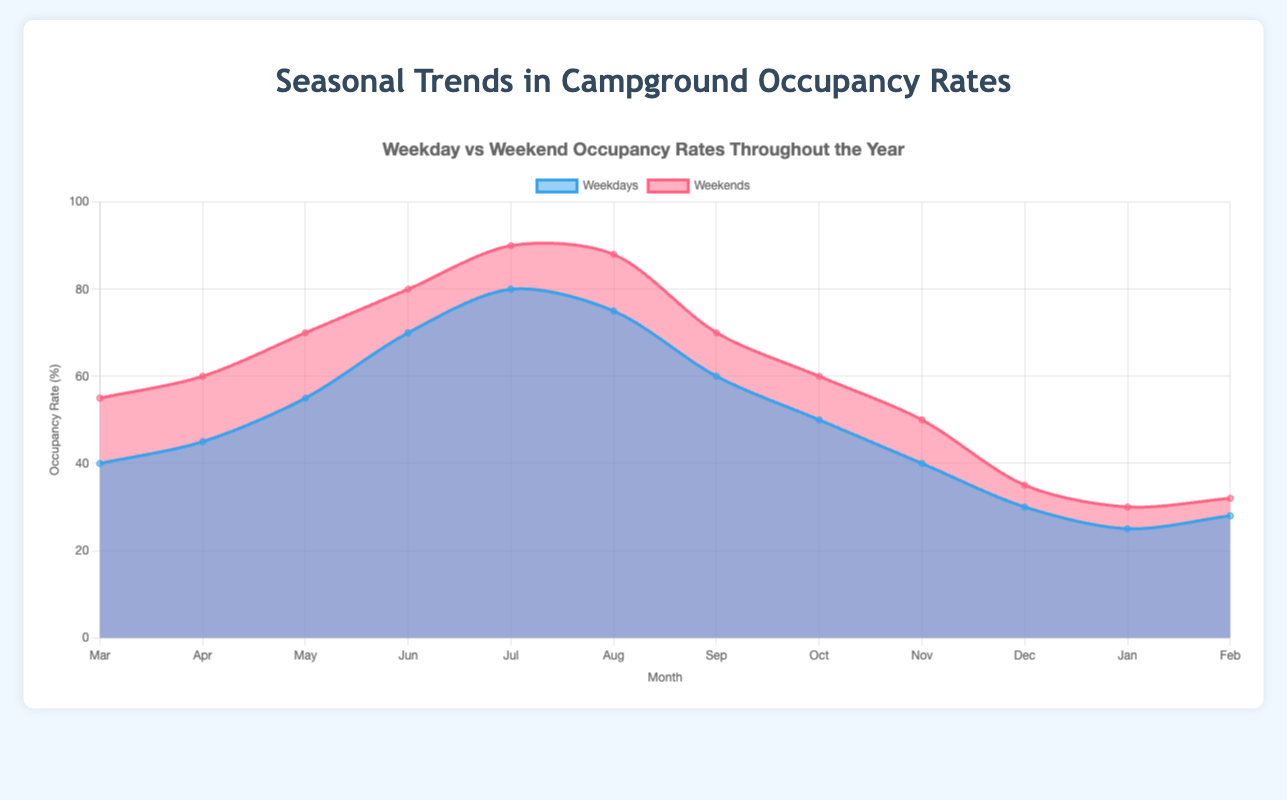What's the title of the chart? Look at the top of the chart where the title is displayed.
Answer: Weekday vs Weekend Occupancy Rates Throughout the Year How many months of data are shown on the chart? Count the labels on the x-axis to determine the number of months displayed.
Answer: 12 Which season has the highest weekend occupancy rate? Look at the colored areas representing weekends and identify the season where the highest peak occurs.
Answer: Summer What are the weekday and weekend occupancy rates in April? Find April on the x-axis and check the values for weekdays and weekends.
Answer: Weekday: 45%, Weekend: 60% Which month has the highest weekday occupancy rate? Identify the peak point of the line representing weekdays.
Answer: July By how much do weekday occupancy rates increase from March to May? Subtract the March occupancy rate from the May occupancy rate for weekdays.
Answer: 15% What is the difference between weekday and weekend occupancy rates in January? Subtract the weekday occupancy rate from the weekend occupancy rate in January.
Answer: 5% During which month do weekends have the lowest occupancy rate? Find the lowest point of the line representing weekends.
Answer: January What is the average occupancy rate for weekdays and weekends in the winter season? Add the occupancy rates for weekdays and weekends in December, January, and February, then divide by 3.
Answer: Weekday: 27.67%, Weekend: 32.33% Compare the trend of occupancy rates in fall to that in summer for weekdays. Observe the slopes of the weekday lines in both fall and summer to compare their trends.
Answer: Fall decreases, summer increases 